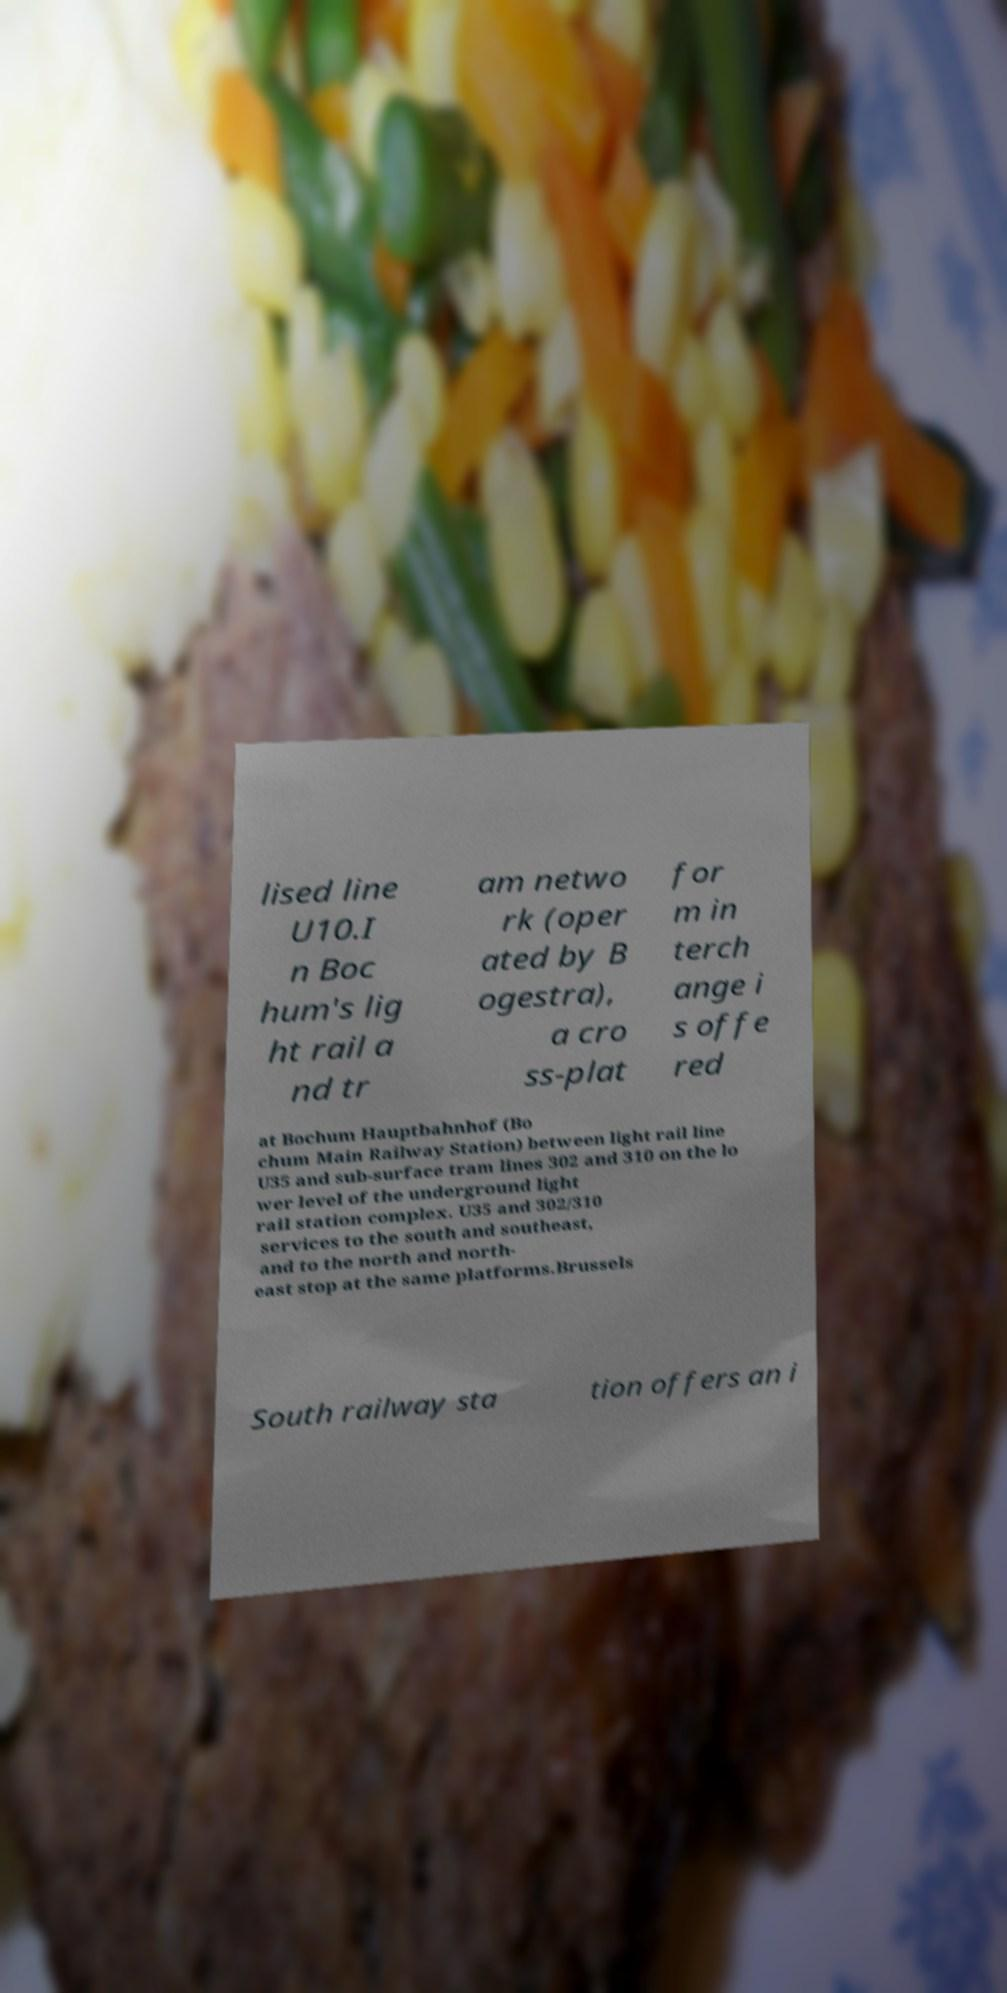Please identify and transcribe the text found in this image. lised line U10.I n Boc hum's lig ht rail a nd tr am netwo rk (oper ated by B ogestra), a cro ss-plat for m in terch ange i s offe red at Bochum Hauptbahnhof (Bo chum Main Railway Station) between light rail line U35 and sub-surface tram lines 302 and 310 on the lo wer level of the underground light rail station complex. U35 and 302/310 services to the south and southeast, and to the north and north- east stop at the same platforms.Brussels South railway sta tion offers an i 